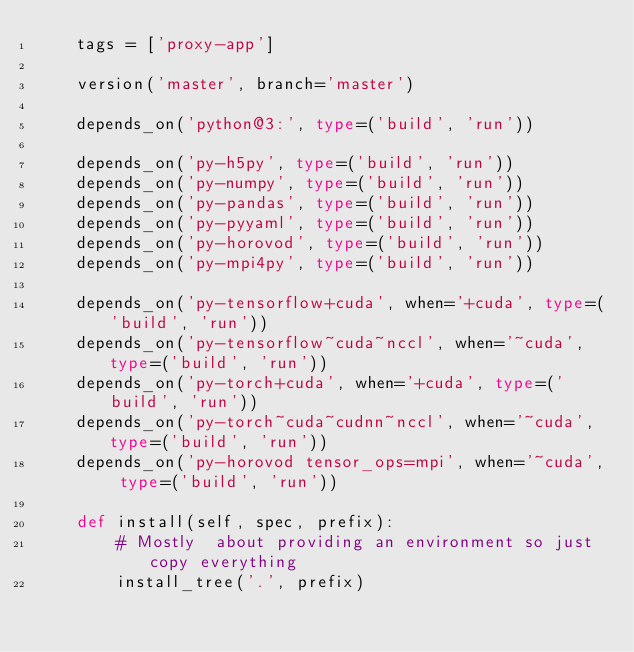Convert code to text. <code><loc_0><loc_0><loc_500><loc_500><_Python_>    tags = ['proxy-app']

    version('master', branch='master')

    depends_on('python@3:', type=('build', 'run'))

    depends_on('py-h5py', type=('build', 'run'))
    depends_on('py-numpy', type=('build', 'run'))
    depends_on('py-pandas', type=('build', 'run'))
    depends_on('py-pyyaml', type=('build', 'run'))
    depends_on('py-horovod', type=('build', 'run'))
    depends_on('py-mpi4py', type=('build', 'run'))

    depends_on('py-tensorflow+cuda', when='+cuda', type=('build', 'run'))
    depends_on('py-tensorflow~cuda~nccl', when='~cuda', type=('build', 'run'))
    depends_on('py-torch+cuda', when='+cuda', type=('build', 'run'))
    depends_on('py-torch~cuda~cudnn~nccl', when='~cuda', type=('build', 'run'))
    depends_on('py-horovod tensor_ops=mpi', when='~cuda', type=('build', 'run'))

    def install(self, spec, prefix):
        # Mostly  about providing an environment so just copy everything
        install_tree('.', prefix)
</code> 